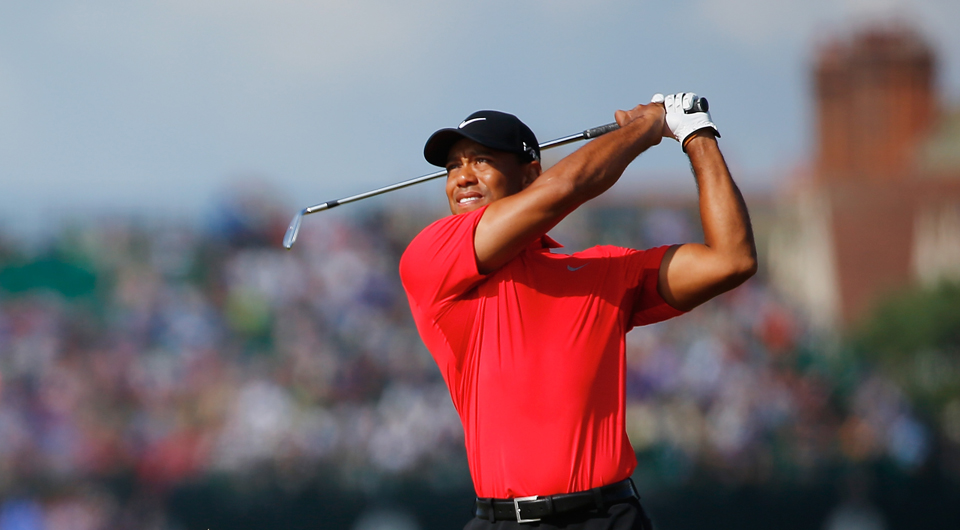Imagine if this event were held in outer space. How do you think the gameplay of golf would be different? If this event were held in outer space, the gameplay of golf would be dramatically different due to the absence of gravity. Golf balls would float rather than land, making traditional shots impossible. Players would have to adjust their swings and aim to account for the lack of gravitational pull. The concept of 'holes' would also change, perhaps involving magnetic targets or using the walls of a space station to create designated scoring areas. The entire dynamics and strategies of the game would shift significantly to adapt to the unique environment of space. 